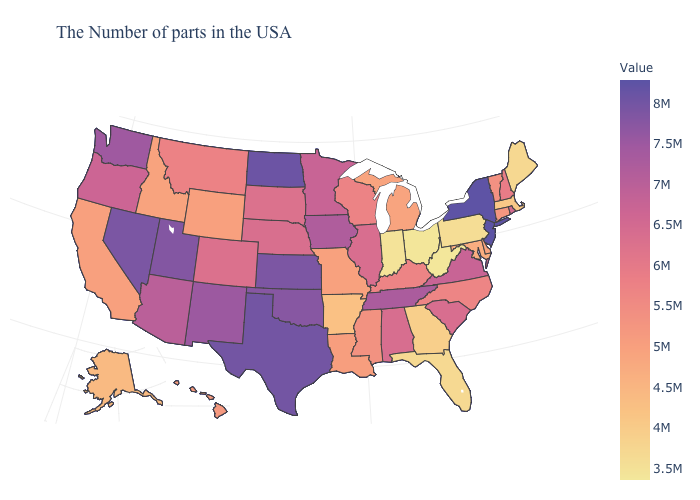Does Colorado have a lower value than Massachusetts?
Write a very short answer. No. Which states hav the highest value in the South?
Be succinct. Texas. Does the map have missing data?
Short answer required. No. Does New Jersey have the highest value in the USA?
Concise answer only. Yes. Among the states that border Michigan , which have the lowest value?
Be succinct. Ohio. Does New Jersey have the highest value in the USA?
Be succinct. Yes. Which states have the lowest value in the MidWest?
Be succinct. Ohio. Which states have the highest value in the USA?
Give a very brief answer. New Jersey. Does Ohio have the lowest value in the MidWest?
Write a very short answer. Yes. 